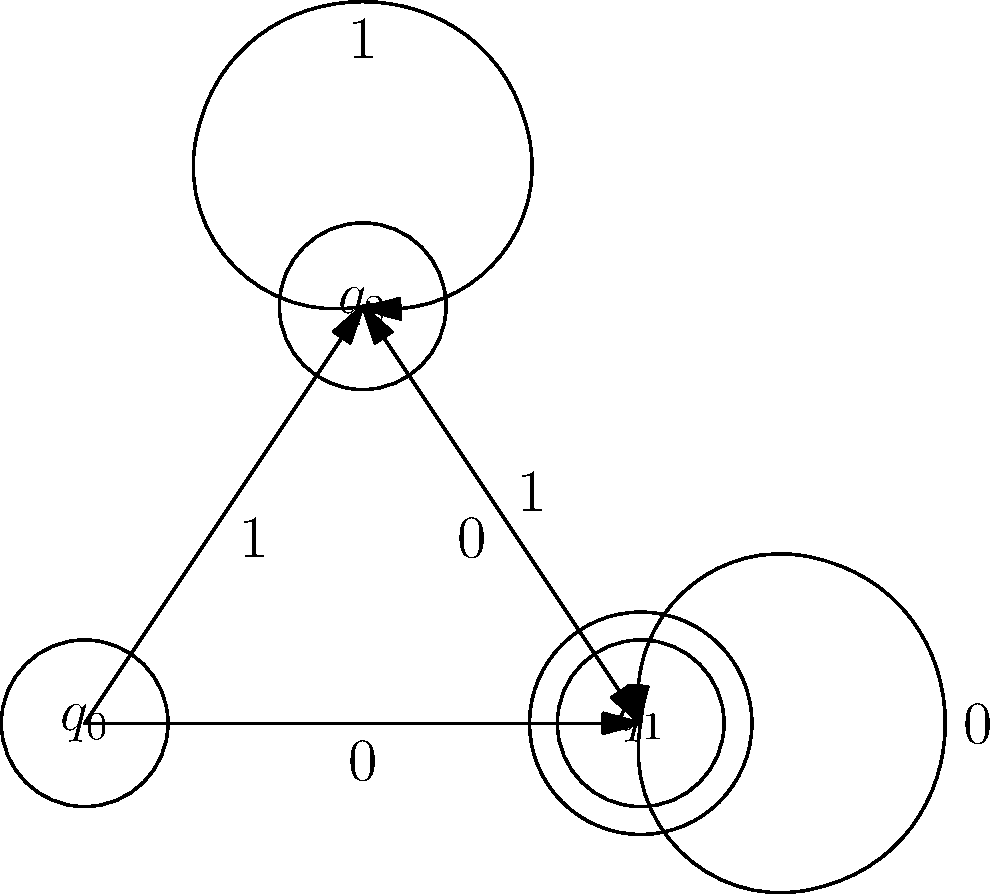Given the deterministic finite automaton (DFA) shown in the diagram, identify the accepting state(s) and explain the language recognized by this DFA. To identify the accepting state(s) and determine the language recognized by this DFA, let's follow these steps:

1. Identify the accepting state(s):
   - In a DFA diagram, accepting states are typically represented by double circles.
   - In this diagram, we can see that state $q_1$ is drawn with a double circle, making it the only accepting state.

2. Analyze the transitions:
   - The DFA has three states: $q_0$ (start state), $q_1$, and $q_2$.
   - Transitions are labeled with input symbols 0 and 1.

3. Trace possible paths to the accepting state:
   - From $q_0$, we can reach $q_1$ directly with input 0.
   - From $q_0$, we can reach $q_2$ with input 1, then reach $q_1$ with input 0.
   - Once in $q_1$, we can stay there with input 0 or move to $q_2$ with input 1.
   - From $q_2$, we can return to $q_1$ with input 0 or stay in $q_2$ with input 1.

4. Determine the language recognized:
   - The DFA accepts strings that end in state $q_1$.
   - To reach $q_1$, the input must end with 0.
   - The string can have any number of 1's followed by 0's, as long as it ends with 0.

5. Formalize the language:
   - The language recognized by this DFA can be described as strings over {0, 1} that end with 0.
   - In regular expression notation, this language can be written as $(0+1)^*0$.

Therefore, the accepting state is $q_1$, and the DFA recognizes the language of all binary strings that end with 0.
Answer: Accepting state: $q_1$. Language: $(0+1)^*0$ 